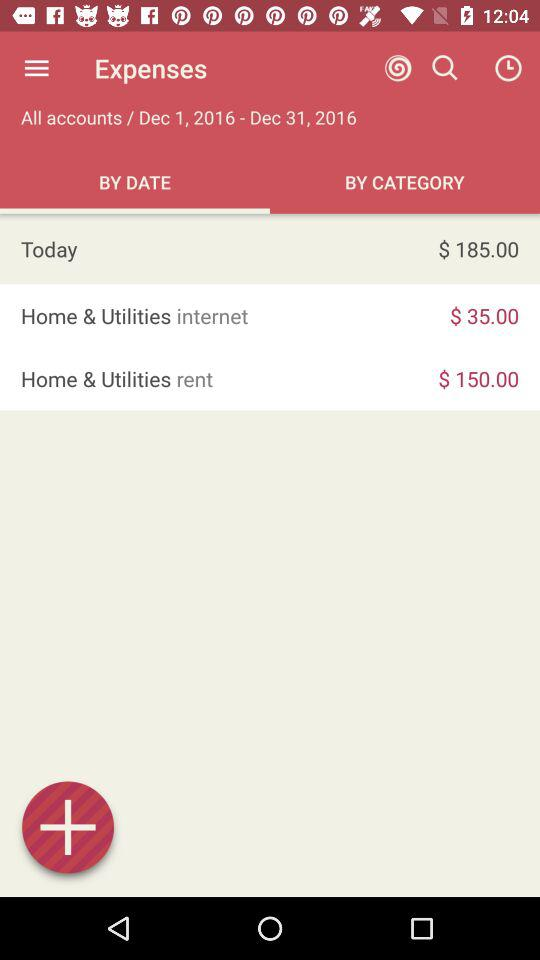Which tab is selected? The selected tab is "BY DATE". 